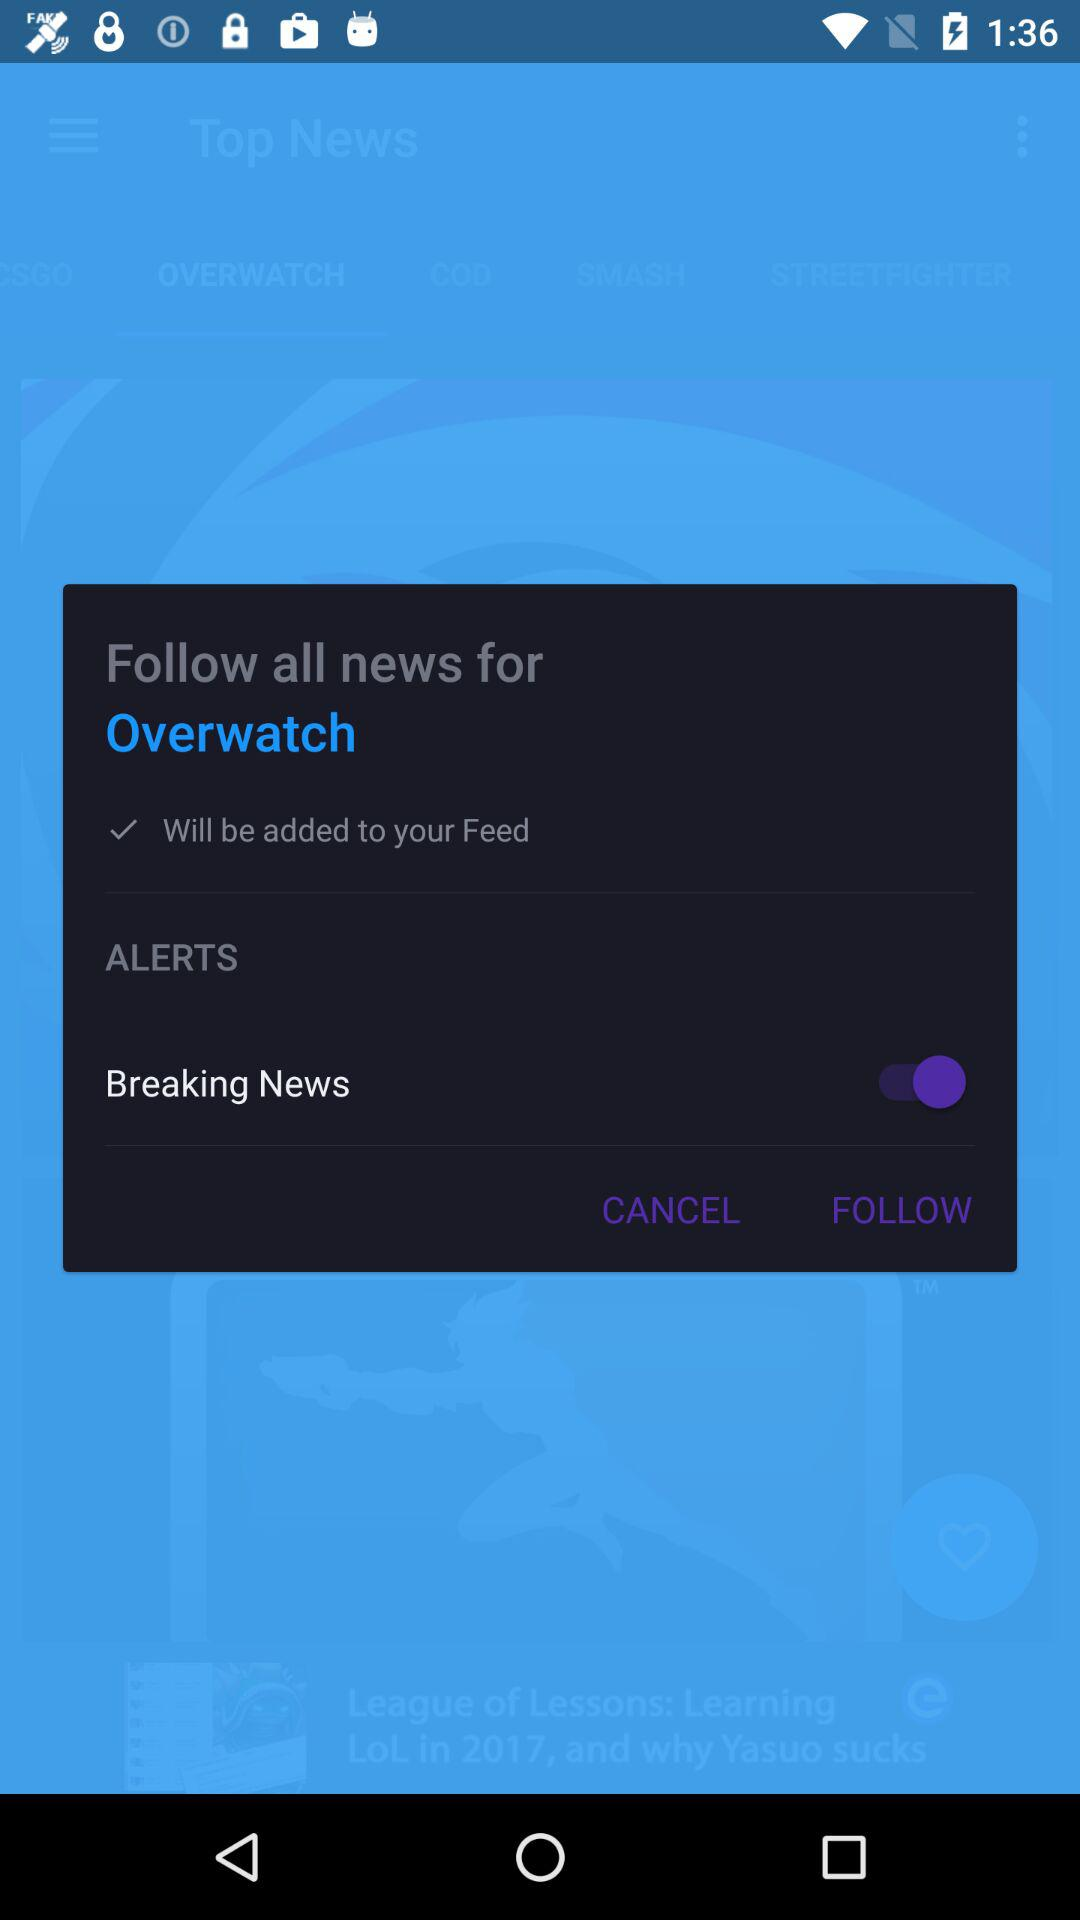What is the status of "Breaking News"? The status is "on". 